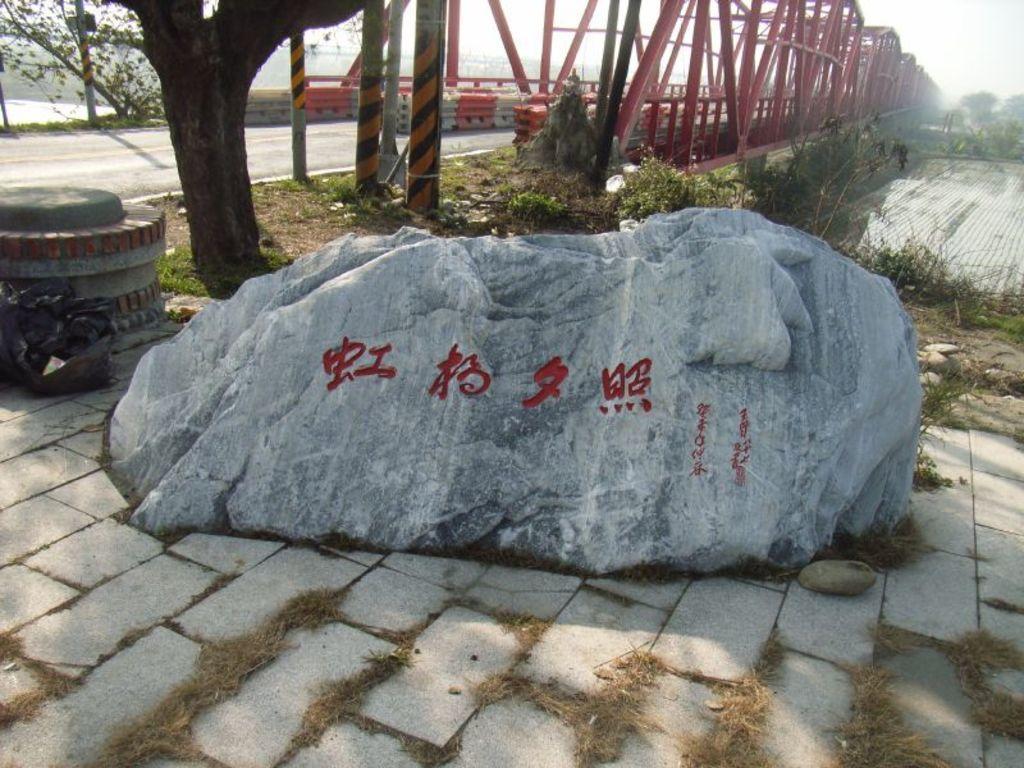In one or two sentences, can you explain what this image depicts? In this picture I can see there is rock and there is some grass and there is a tree, a road and plants. There is a bridge here at right, it is has a red color iron frame. 